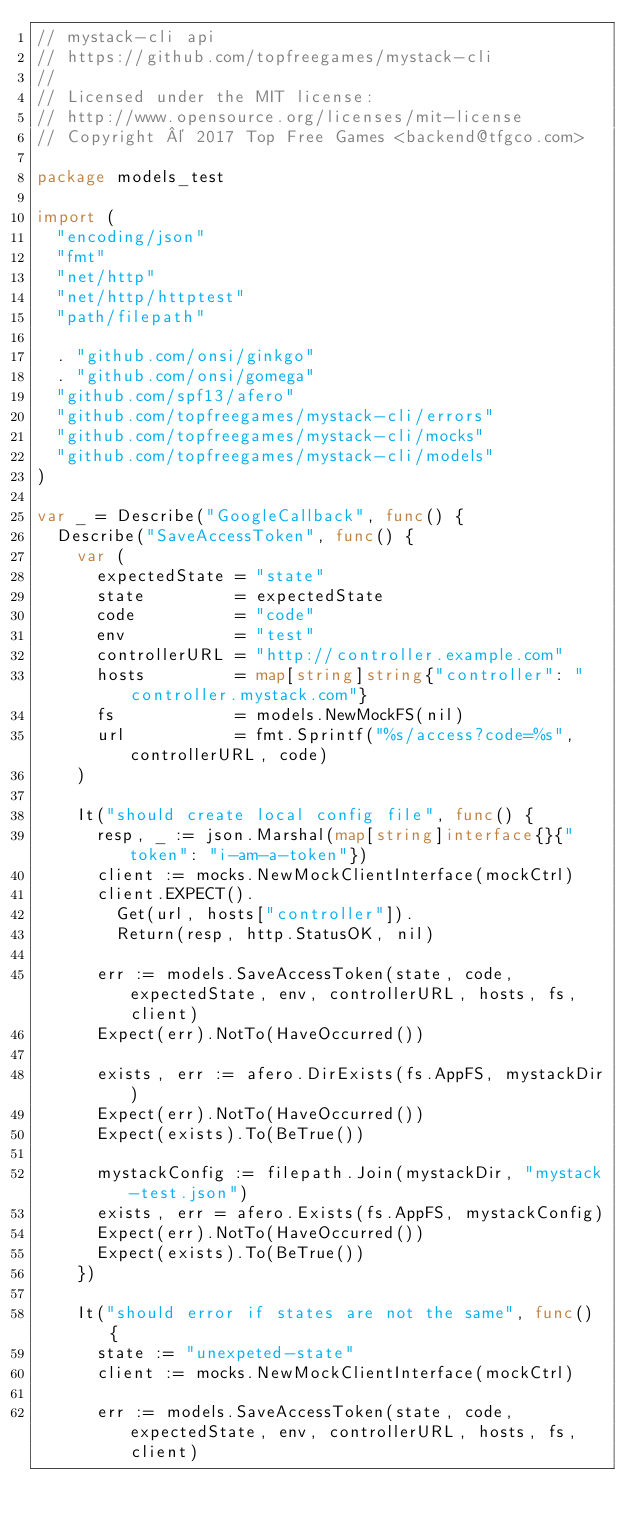Convert code to text. <code><loc_0><loc_0><loc_500><loc_500><_Go_>// mystack-cli api
// https://github.com/topfreegames/mystack-cli
//
// Licensed under the MIT license:
// http://www.opensource.org/licenses/mit-license
// Copyright © 2017 Top Free Games <backend@tfgco.com>

package models_test

import (
	"encoding/json"
	"fmt"
	"net/http"
	"net/http/httptest"
	"path/filepath"

	. "github.com/onsi/ginkgo"
	. "github.com/onsi/gomega"
	"github.com/spf13/afero"
	"github.com/topfreegames/mystack-cli/errors"
	"github.com/topfreegames/mystack-cli/mocks"
	"github.com/topfreegames/mystack-cli/models"
)

var _ = Describe("GoogleCallback", func() {
	Describe("SaveAccessToken", func() {
		var (
			expectedState = "state"
			state         = expectedState
			code          = "code"
			env           = "test"
			controllerURL = "http://controller.example.com"
			hosts         = map[string]string{"controller": "controller.mystack.com"}
			fs            = models.NewMockFS(nil)
			url           = fmt.Sprintf("%s/access?code=%s", controllerURL, code)
		)

		It("should create local config file", func() {
			resp, _ := json.Marshal(map[string]interface{}{"token": "i-am-a-token"})
			client := mocks.NewMockClientInterface(mockCtrl)
			client.EXPECT().
				Get(url, hosts["controller"]).
				Return(resp, http.StatusOK, nil)

			err := models.SaveAccessToken(state, code, expectedState, env, controllerURL, hosts, fs, client)
			Expect(err).NotTo(HaveOccurred())

			exists, err := afero.DirExists(fs.AppFS, mystackDir)
			Expect(err).NotTo(HaveOccurred())
			Expect(exists).To(BeTrue())

			mystackConfig := filepath.Join(mystackDir, "mystack-test.json")
			exists, err = afero.Exists(fs.AppFS, mystackConfig)
			Expect(err).NotTo(HaveOccurred())
			Expect(exists).To(BeTrue())
		})

		It("should error if states are not the same", func() {
			state := "unexpeted-state"
			client := mocks.NewMockClientInterface(mockCtrl)

			err := models.SaveAccessToken(state, code, expectedState, env, controllerURL, hosts, fs, client)</code> 